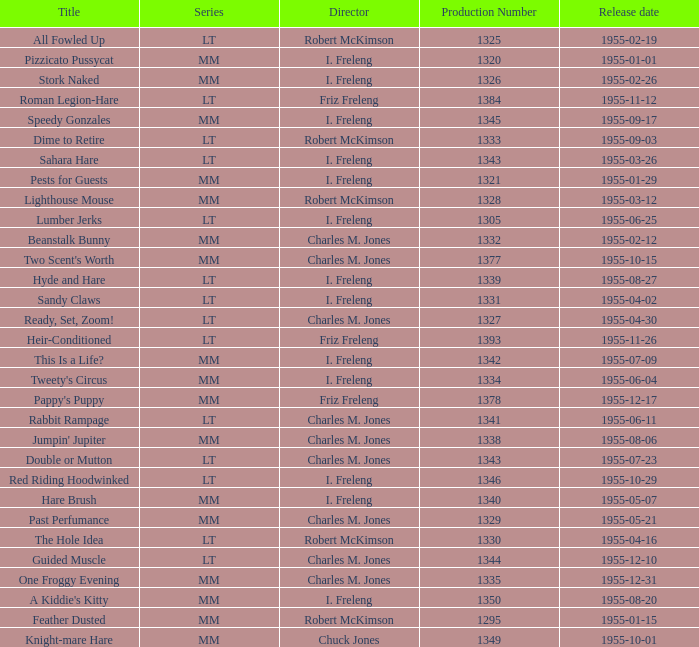Write the full table. {'header': ['Title', 'Series', 'Director', 'Production Number', 'Release date'], 'rows': [['All Fowled Up', 'LT', 'Robert McKimson', '1325', '1955-02-19'], ['Pizzicato Pussycat', 'MM', 'I. Freleng', '1320', '1955-01-01'], ['Stork Naked', 'MM', 'I. Freleng', '1326', '1955-02-26'], ['Roman Legion-Hare', 'LT', 'Friz Freleng', '1384', '1955-11-12'], ['Speedy Gonzales', 'MM', 'I. Freleng', '1345', '1955-09-17'], ['Dime to Retire', 'LT', 'Robert McKimson', '1333', '1955-09-03'], ['Sahara Hare', 'LT', 'I. Freleng', '1343', '1955-03-26'], ['Pests for Guests', 'MM', 'I. Freleng', '1321', '1955-01-29'], ['Lighthouse Mouse', 'MM', 'Robert McKimson', '1328', '1955-03-12'], ['Lumber Jerks', 'LT', 'I. Freleng', '1305', '1955-06-25'], ['Beanstalk Bunny', 'MM', 'Charles M. Jones', '1332', '1955-02-12'], ["Two Scent's Worth", 'MM', 'Charles M. Jones', '1377', '1955-10-15'], ['Hyde and Hare', 'LT', 'I. Freleng', '1339', '1955-08-27'], ['Sandy Claws', 'LT', 'I. Freleng', '1331', '1955-04-02'], ['Ready, Set, Zoom!', 'LT', 'Charles M. Jones', '1327', '1955-04-30'], ['Heir-Conditioned', 'LT', 'Friz Freleng', '1393', '1955-11-26'], ['This Is a Life?', 'MM', 'I. Freleng', '1342', '1955-07-09'], ["Tweety's Circus", 'MM', 'I. Freleng', '1334', '1955-06-04'], ["Pappy's Puppy", 'MM', 'Friz Freleng', '1378', '1955-12-17'], ['Rabbit Rampage', 'LT', 'Charles M. Jones', '1341', '1955-06-11'], ["Jumpin' Jupiter", 'MM', 'Charles M. Jones', '1338', '1955-08-06'], ['Double or Mutton', 'LT', 'Charles M. Jones', '1343', '1955-07-23'], ['Red Riding Hoodwinked', 'LT', 'I. Freleng', '1346', '1955-10-29'], ['Hare Brush', 'MM', 'I. Freleng', '1340', '1955-05-07'], ['Past Perfumance', 'MM', 'Charles M. Jones', '1329', '1955-05-21'], ['The Hole Idea', 'LT', 'Robert McKimson', '1330', '1955-04-16'], ['Guided Muscle', 'LT', 'Charles M. Jones', '1344', '1955-12-10'], ['One Froggy Evening', 'MM', 'Charles M. Jones', '1335', '1955-12-31'], ["A Kiddie's Kitty", 'MM', 'I. Freleng', '1350', '1955-08-20'], ['Feather Dusted', 'MM', 'Robert McKimson', '1295', '1955-01-15'], ['Knight-mare Hare', 'MM', 'Chuck Jones', '1349', '1955-10-01']]} What is the release date of production number 1327? 1955-04-30. 